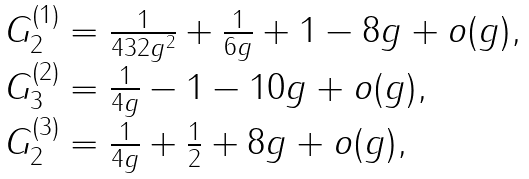Convert formula to latex. <formula><loc_0><loc_0><loc_500><loc_500>\begin{array} { l } G ^ { ( 1 ) } _ { 2 } = \frac { 1 } { 4 3 2 g ^ { 2 } } + \frac { 1 } { 6 g } + 1 - 8 g + o ( g ) , \\ G ^ { ( 2 ) } _ { 3 } = \frac { 1 } { 4 g } - 1 - 1 0 g + o ( g ) , \\ G ^ { ( 3 ) } _ { 2 } = \frac { 1 } { 4 g } + \frac { 1 } { 2 } + 8 g + o ( g ) , \end{array}</formula> 